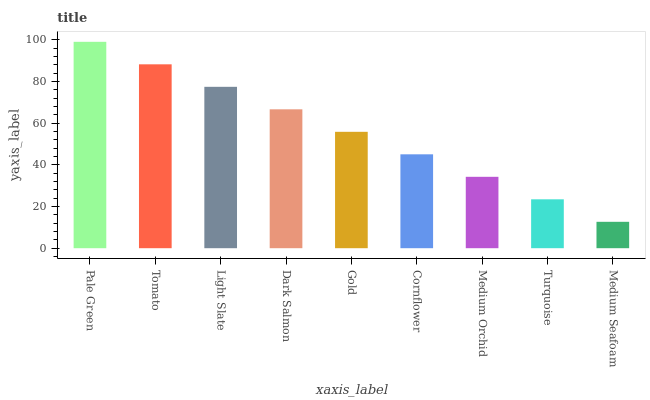Is Medium Seafoam the minimum?
Answer yes or no. Yes. Is Pale Green the maximum?
Answer yes or no. Yes. Is Tomato the minimum?
Answer yes or no. No. Is Tomato the maximum?
Answer yes or no. No. Is Pale Green greater than Tomato?
Answer yes or no. Yes. Is Tomato less than Pale Green?
Answer yes or no. Yes. Is Tomato greater than Pale Green?
Answer yes or no. No. Is Pale Green less than Tomato?
Answer yes or no. No. Is Gold the high median?
Answer yes or no. Yes. Is Gold the low median?
Answer yes or no. Yes. Is Cornflower the high median?
Answer yes or no. No. Is Medium Seafoam the low median?
Answer yes or no. No. 